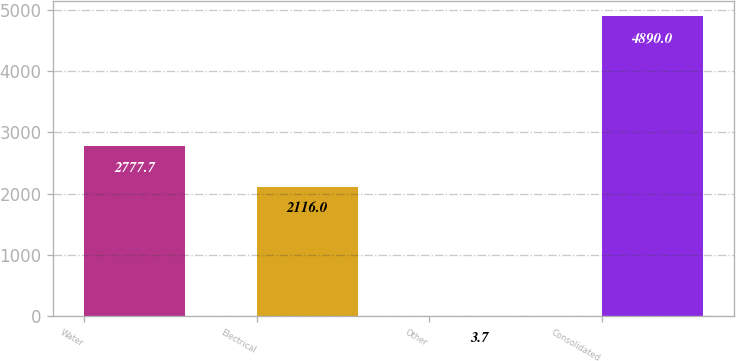Convert chart. <chart><loc_0><loc_0><loc_500><loc_500><bar_chart><fcel>Water<fcel>Electrical<fcel>Other<fcel>Consolidated<nl><fcel>2777.7<fcel>2116<fcel>3.7<fcel>4890<nl></chart> 